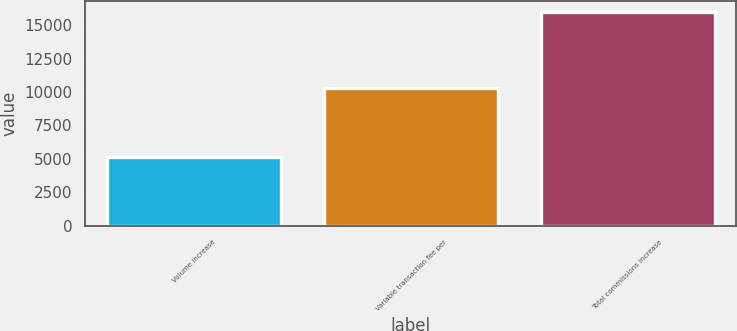<chart> <loc_0><loc_0><loc_500><loc_500><bar_chart><fcel>Volume increase<fcel>Variable transaction fee per<fcel>Total commissions increase<nl><fcel>5134<fcel>10332<fcel>16010<nl></chart> 